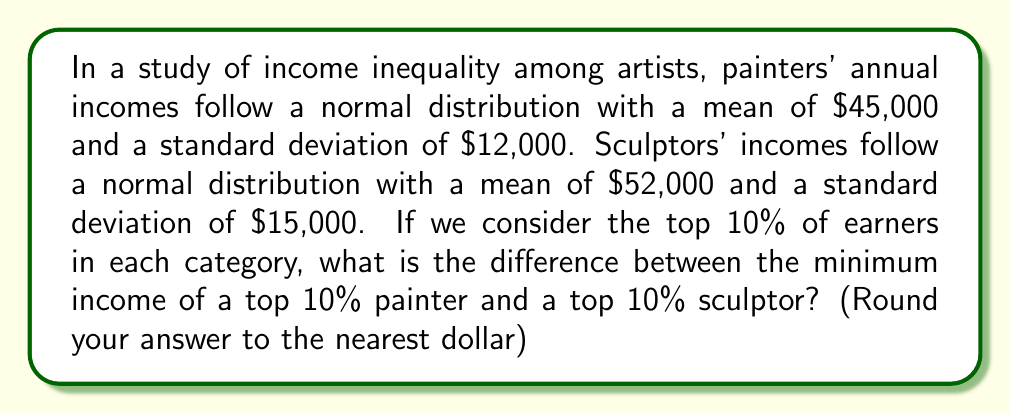Show me your answer to this math problem. Let's approach this step-by-step:

1) For a normal distribution, the top 10% of values lie above the 90th percentile.

2) To find the 90th percentile, we need to find the z-score corresponding to the 90th percentile, which is approximately 1.28.

3) For painters:
   Mean ($\mu_p$) = $45,000
   Standard deviation ($\sigma_p$) = $12,000
   
   The formula for the 90th percentile is:
   $$X = \mu + (z \times \sigma)$$
   
   So, for painters:
   $$X_p = 45,000 + (1.28 \times 12,000) = 60,360$$

4) For sculptors:
   Mean ($\mu_s$) = $52,000
   Standard deviation ($\sigma_s$) = $15,000
   
   Using the same formula:
   $$X_s = 52,000 + (1.28 \times 15,000) = 71,200$$

5) The difference between these values is:
   $$71,200 - 60,360 = 10,840$$

Therefore, the difference between the minimum income of a top 10% sculptor and a top 10% painter is $10,840.
Answer: $10,840 